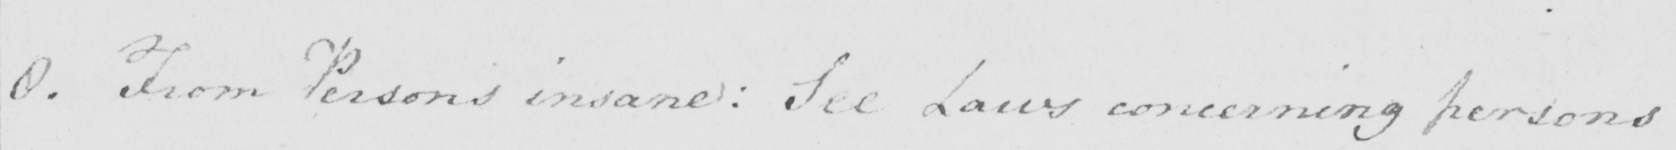What is written in this line of handwriting? 8 . From Persons insane :  See Laws concerning persons 